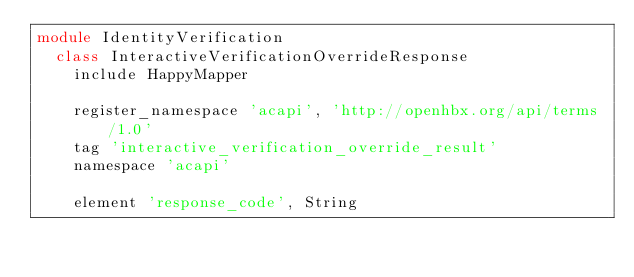Convert code to text. <code><loc_0><loc_0><loc_500><loc_500><_Ruby_>module IdentityVerification
  class InteractiveVerificationOverrideResponse
    include HappyMapper

    register_namespace 'acapi', 'http://openhbx.org/api/terms/1.0'
    tag 'interactive_verification_override_result'
    namespace 'acapi'

    element 'response_code', String</code> 